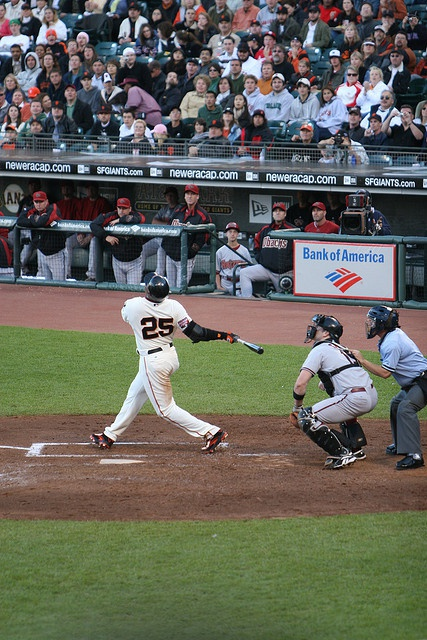Describe the objects in this image and their specific colors. I can see people in gray, black, darkgray, and blue tones, people in gray, lightgray, black, and darkgray tones, people in gray, black, lavender, and darkgray tones, people in gray, black, darkblue, and darkgray tones, and people in gray, black, and darkgray tones in this image. 